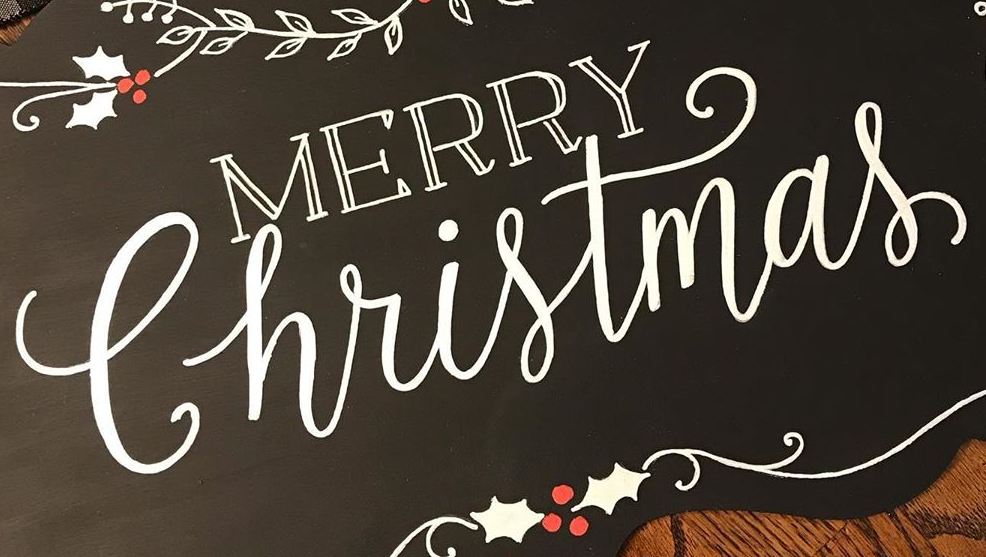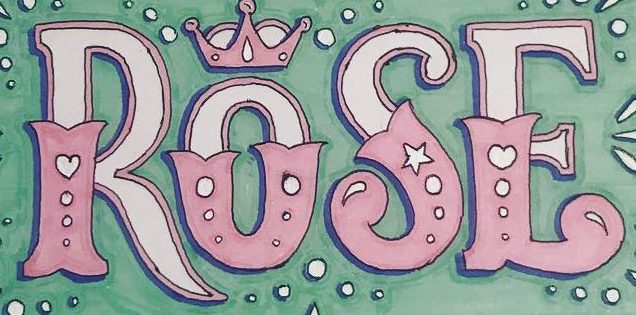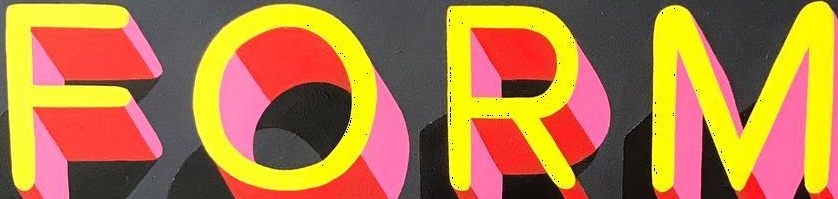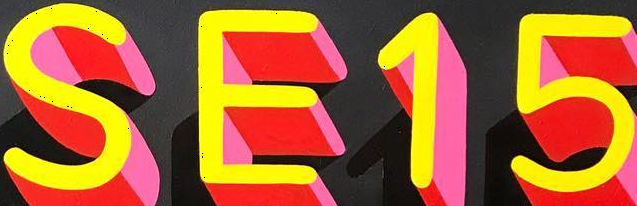What text is displayed in these images sequentially, separated by a semicolon? Christmas; ROSE; FORM; SE15 